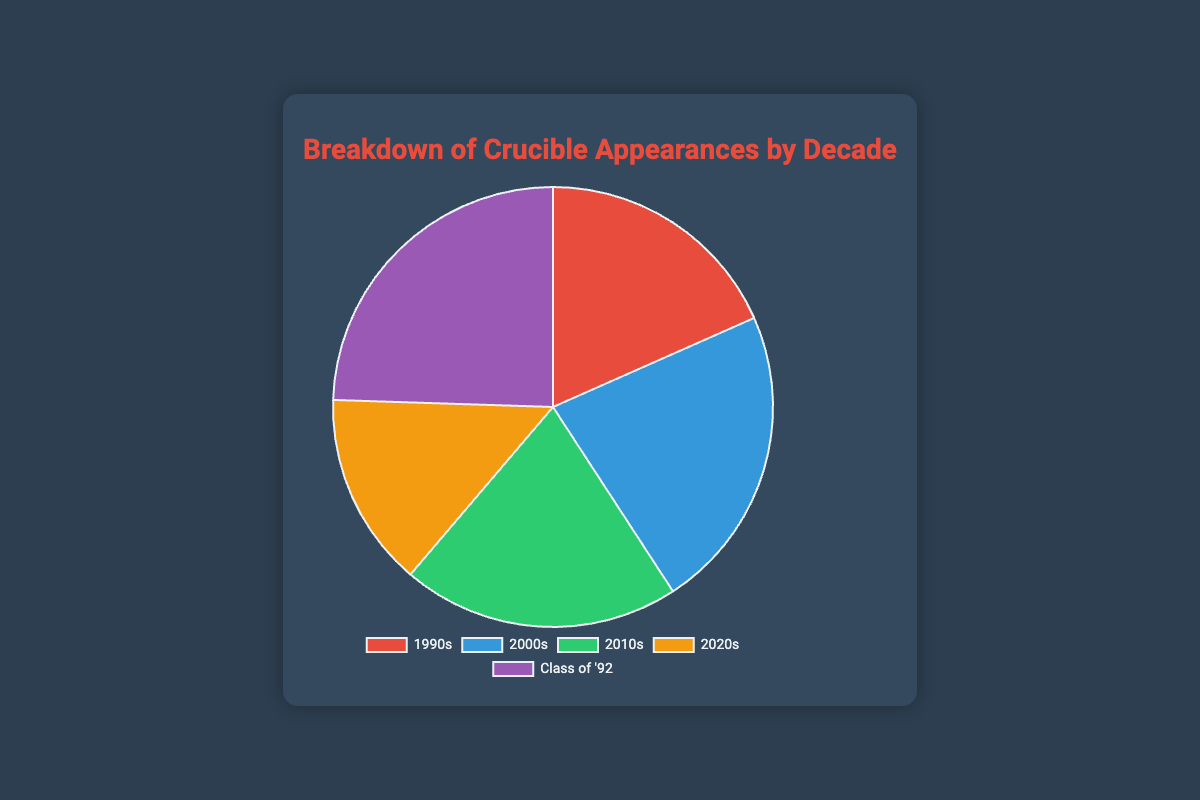Which decade has the highest number of Crucible appearances? The pie chart shows different segments representing the number of Crucible appearances by decade. By comparing the sizes of the segments, the "Class of '92" segment is the largest.
Answer: The Class of '92 How does the number of appearances in the 2010s compare to the 2000s? By examining the pie chart, we see that the 2000s segment is larger than the 2010s segment. The 2000s have 55 appearances, and the 2010s have 50.
Answer: The 2000s have more What is the total number of Crucible appearances combining the 1990s and the 2020s? Summing the appearances in the 1990s (45) and 2020s (35) gives us 45 + 35 = 80.
Answer: 80 Which segment is represented by the green color? The pie chart uses different colors for each segment. By locating the green segment, we can see it represents the 2010s.
Answer: The 2010s What is the total number of Crucible appearances for all decades, excluding the Class of '92? Summing the appearances for the 1990s, 2000s, 2010s, and 2020s gives 45 + 55 + 50 + 35 = 185.
Answer: 185 How many more appearances does the Class of '92 have compared to the 2020s? Subtracting the 2020s appearances (35) from the Class of '92 appearances (60) gives us 60 - 35 = 25.
Answer: 25 What percentage of the total Crucible appearances does the 2000s represent? Total appearances are 45+55+50+35+60 = 245. The 2000s have 55 appearances. So the percentage is (55 / 245) * 100 ≈ 22.45%.
Answer: 22.45% Which decade has the fewest number of Crucible appearances? By comparing the segment sizes, the "2020s" segment is the smallest. Thus, the 2020s have the fewest appearances.
Answer: The 2020s What is the average number of appearances per decade, including the Class of '92 as a separate category? The sum of all appearances is 45+55+50+35+60 = 245. With 5 groups, the average is 245 / 5 = 49.
Answer: 49 